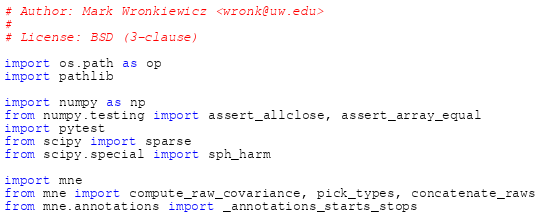Convert code to text. <code><loc_0><loc_0><loc_500><loc_500><_Python_># Author: Mark Wronkiewicz <wronk@uw.edu>
#
# License: BSD (3-clause)

import os.path as op
import pathlib

import numpy as np
from numpy.testing import assert_allclose, assert_array_equal
import pytest
from scipy import sparse
from scipy.special import sph_harm

import mne
from mne import compute_raw_covariance, pick_types, concatenate_raws
from mne.annotations import _annotations_starts_stops</code> 